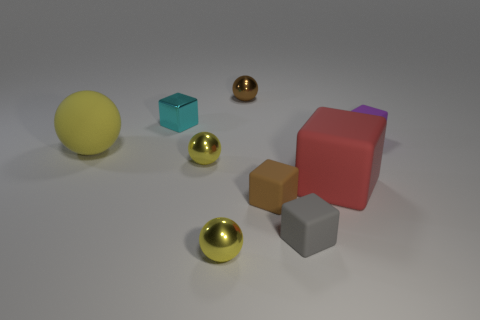There is a matte ball; does it have the same color as the thing that is in front of the gray cube?
Keep it short and to the point. Yes. How many shiny balls have the same color as the rubber ball?
Ensure brevity in your answer.  2. There is a tiny ball in front of the big matte thing on the right side of the sphere behind the purple matte object; what is it made of?
Offer a terse response. Metal. What color is the cube that is the same material as the small brown sphere?
Make the answer very short. Cyan. How many big things are in front of the ball to the right of the yellow metal object in front of the brown block?
Your response must be concise. 2. What number of things are tiny brown objects that are behind the large yellow matte ball or purple blocks?
Make the answer very short. 2. There is a small ball in front of the brown matte object; is it the same color as the large rubber ball?
Offer a very short reply. Yes. There is a small yellow thing that is behind the big thing that is to the right of the gray matte object; what is its shape?
Give a very brief answer. Sphere. Are there fewer tiny metal cubes in front of the small brown matte thing than tiny brown objects behind the yellow rubber thing?
Your response must be concise. Yes. There is a gray matte object that is the same shape as the red thing; what size is it?
Your answer should be compact. Small. 